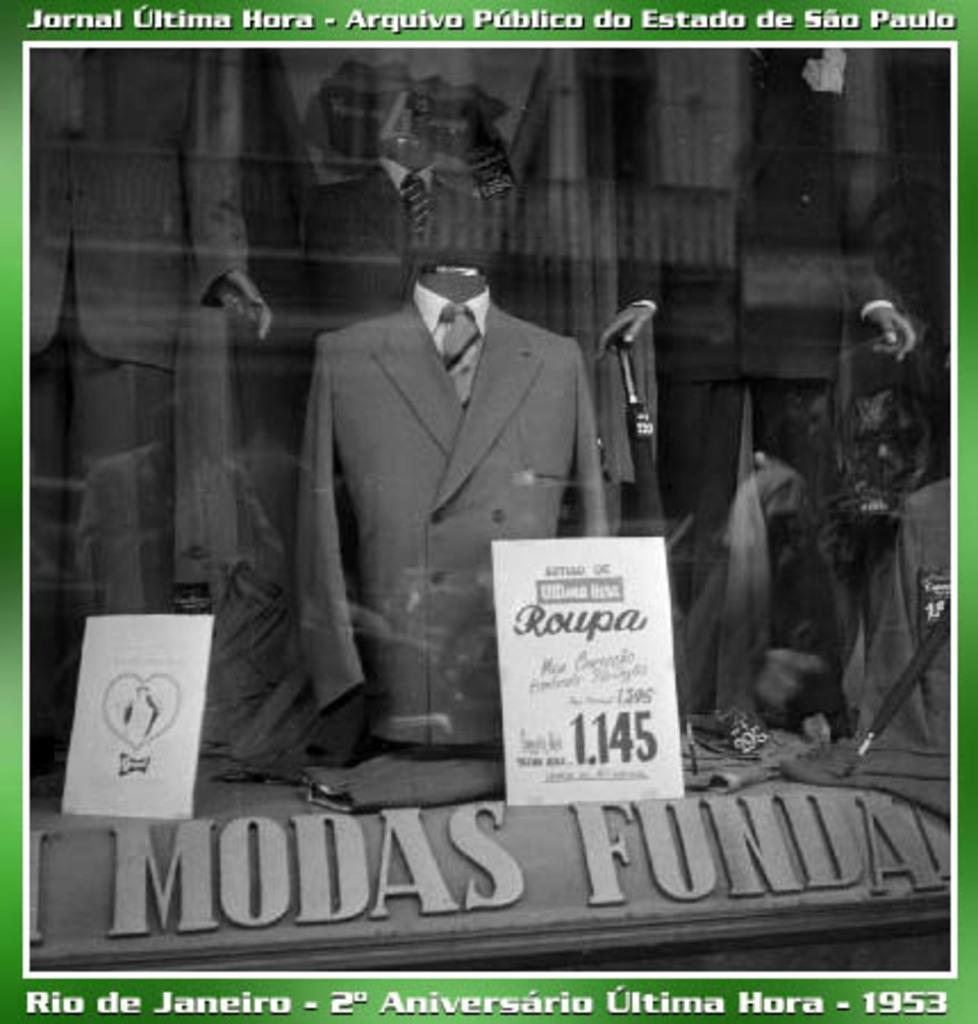What type of objects can be seen in the image? There are mannequins in the image. What are the mannequins wearing? Clothes are placed on the mannequins. Can you describe any text in the image? There is text at the top and bottom of the image. What else can be seen in the image besides the mannequins and text? There are boards visible in the image. What type of mint can be seen growing on the boards in the image? There is no mint visible in the image; the boards are not associated with any plants or vegetation. 